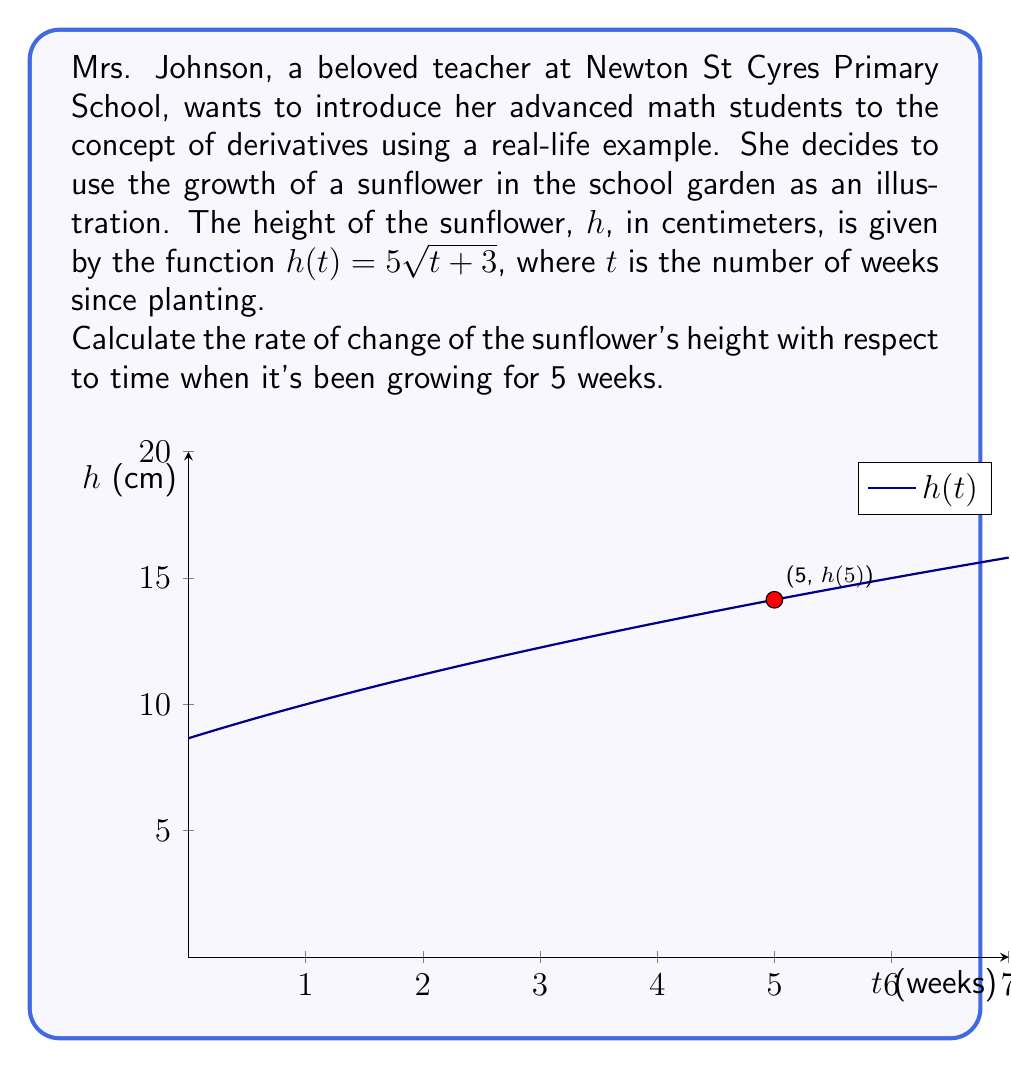What is the answer to this math problem? Let's approach this step-by-step using the chain rule:

1) We have $h(t) = 5\sqrt{t+3}$. This is a composite function where the outer function is $f(x) = 5x$ and the inner function is $g(t) = \sqrt{t+3}$.

2) The chain rule states that if $h(t) = f(g(t))$, then $h'(t) = f'(g(t)) \cdot g'(t)$.

3) Let's find $f'(x)$ and $g'(t)$ separately:
   
   $f'(x) = 5$ (the derivative of $5x$ is just 5)
   
   $g'(t) = \frac{1}{2\sqrt{t+3}}$ (using the power rule for $\sqrt{t+3} = (t+3)^{\frac{1}{2}}$)

4) Now, applying the chain rule:

   $h'(t) = f'(g(t)) \cdot g'(t) = 5 \cdot \frac{1}{2\sqrt{t+3}} = \frac{5}{2\sqrt{t+3}}$

5) To find the rate of change at 5 weeks, we substitute $t=5$ into our derivative function:

   $h'(5) = \frac{5}{2\sqrt{5+3}} = \frac{5}{2\sqrt{8}} = \frac{5}{2\cdot 2\sqrt{2}} = \frac{5}{4\sqrt{2}} \approx 0.8839$ cm/week

Therefore, after 5 weeks, the sunflower is growing at a rate of approximately 0.8839 cm per week.
Answer: $\frac{5}{4\sqrt{2}}$ cm/week 